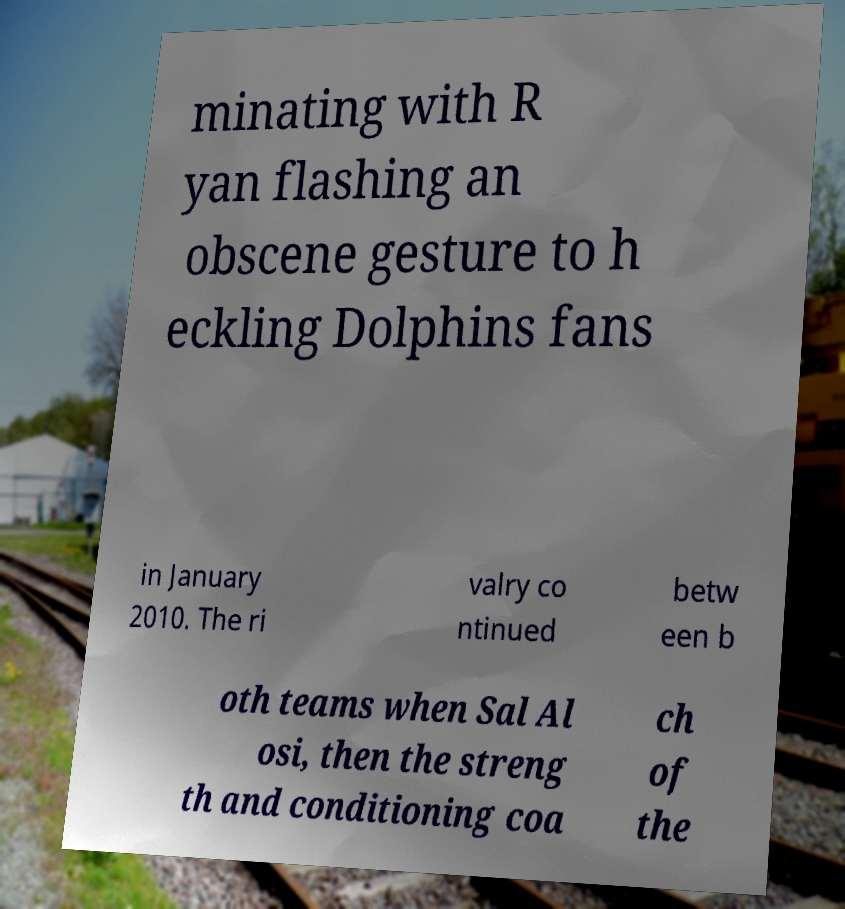Can you read and provide the text displayed in the image?This photo seems to have some interesting text. Can you extract and type it out for me? minating with R yan flashing an obscene gesture to h eckling Dolphins fans in January 2010. The ri valry co ntinued betw een b oth teams when Sal Al osi, then the streng th and conditioning coa ch of the 